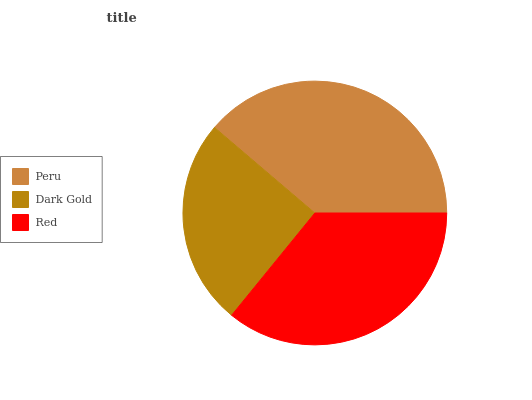Is Dark Gold the minimum?
Answer yes or no. Yes. Is Peru the maximum?
Answer yes or no. Yes. Is Red the minimum?
Answer yes or no. No. Is Red the maximum?
Answer yes or no. No. Is Red greater than Dark Gold?
Answer yes or no. Yes. Is Dark Gold less than Red?
Answer yes or no. Yes. Is Dark Gold greater than Red?
Answer yes or no. No. Is Red less than Dark Gold?
Answer yes or no. No. Is Red the high median?
Answer yes or no. Yes. Is Red the low median?
Answer yes or no. Yes. Is Dark Gold the high median?
Answer yes or no. No. Is Peru the low median?
Answer yes or no. No. 